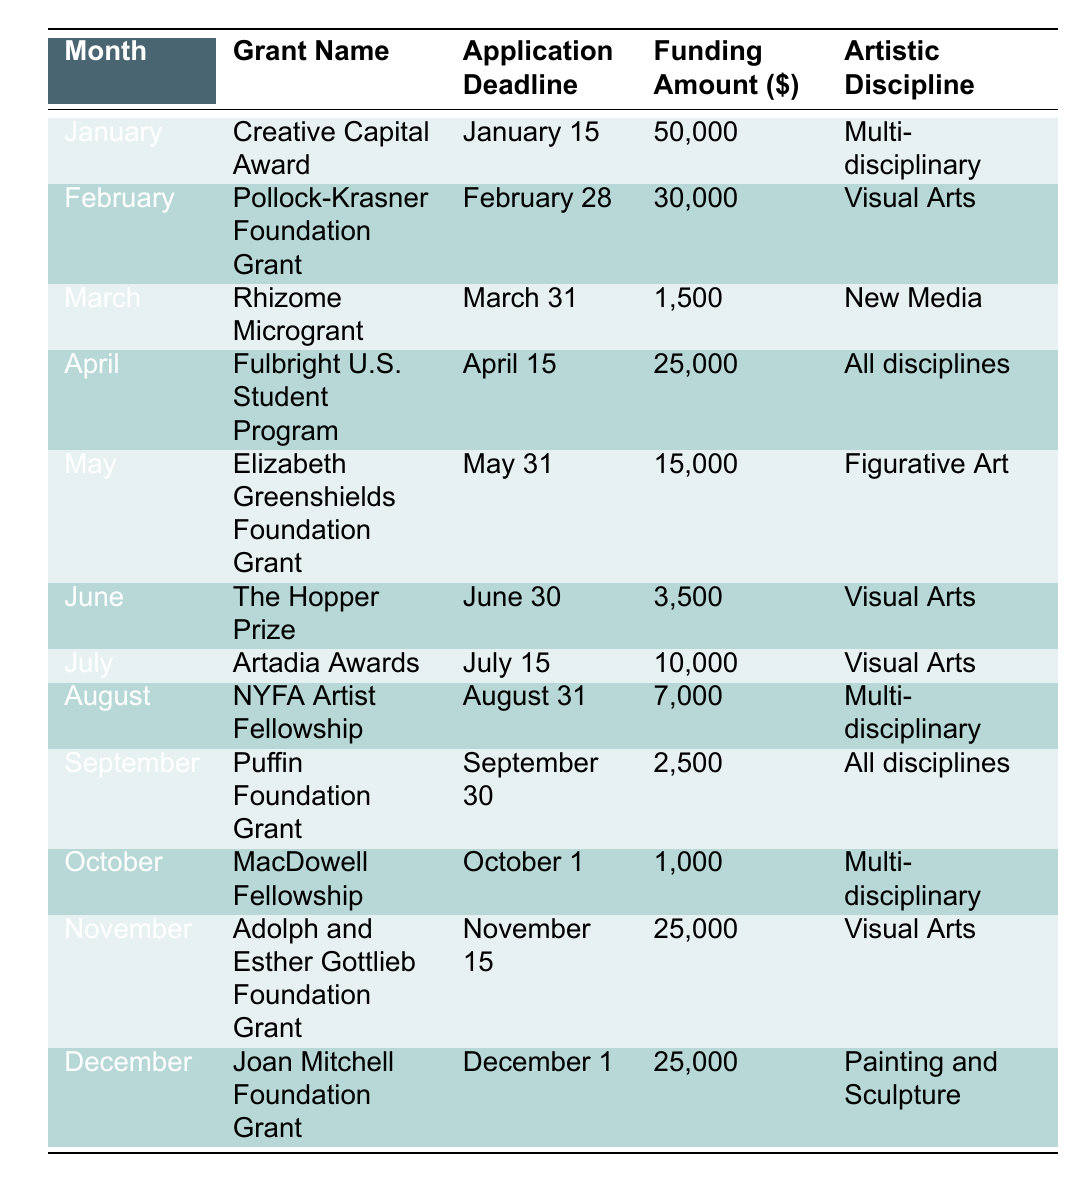What is the funding amount for the Creative Capital Award? It is listed in the table under "Funding Amount ($)" for the "Creative Capital Award," which is in January. The funding amount is 50,000.
Answer: 50,000 Which month has the highest funding amount listed? By examining the "Funding Amount ($)" column, the Creative Capital Award in January has the highest amount of 50,000, more than any other listed grant.
Answer: January Are there any grants available in the month of April? The table includes the Fulbright U.S. Student Program in April with a specified funding amount, so yes, there is a grant available in that month.
Answer: Yes What is the total funding amount available from the grants listed in March and June? The Rhizome Microgrant in March offers 1,500, and The Hopper Prize in June offers 3,500. Adding these amounts gives 1,500 + 3,500 = 5,000.
Answer: 5,000 How many grants are available for the artistic discipline "Visual Arts"? Counting the rows where "Visual Arts" is mentioned, there are four entries: Pollock-Krasner Foundation Grant, The Hopper Prize, Artadia Awards, and the Adolph and Esther Gottlieb Foundation Grant.
Answer: 4 What is the average funding amount for all listed grants? Summing all funding amounts gives (50,000 + 30,000 + 1,500 + 25,000 + 15,000 + 3,500 + 10,000 + 7,000 + 2,500 + 1,000 + 25,000 + 25,000) = 169,000. There are 12 entries, so dividing gives 169,000 / 12 = approximately 14,083.33.
Answer: 14,083.33 Is the Joan Mitchell Foundation Grant available for all artistic disciplines? The table specifies that the Joan Mitchell Foundation Grant is for "Painting and Sculpture," not all disciplines. Therefore, the answer is no.
Answer: No Which grant has an application deadline closest to the end of the year? Looking for the application deadlines, the Joan Mitchell Foundation Grant has a deadline on December 1, which is closest to the end of the year compared to other grants.
Answer: Joan Mitchell Foundation Grant What is the difference in funding amount between the highest and lowest grants listed? The highest grant is the Creative Capital Award at 50,000, and the lowest is the MacDowell Fellowship at 1,000. The difference is 50,000 - 1,000 = 49,000.
Answer: 49,000 Which grants are available in the summer months (June, July, August)? The table lists three grants for summer: The Hopper Prize in June (3,500), Artadia Awards in July (10,000), and NYFA Artist Fellowship in August (7,000).
Answer: 3 grants Are there funding opportunities available specifically for Figurative Art? The Elizabeth Greenshields Foundation Grant is specified as being for Figurative Art, so there is a relevant funding opportunity.
Answer: Yes 